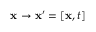<formula> <loc_0><loc_0><loc_500><loc_500>x \to x ^ { \prime } = [ x , t ]</formula> 